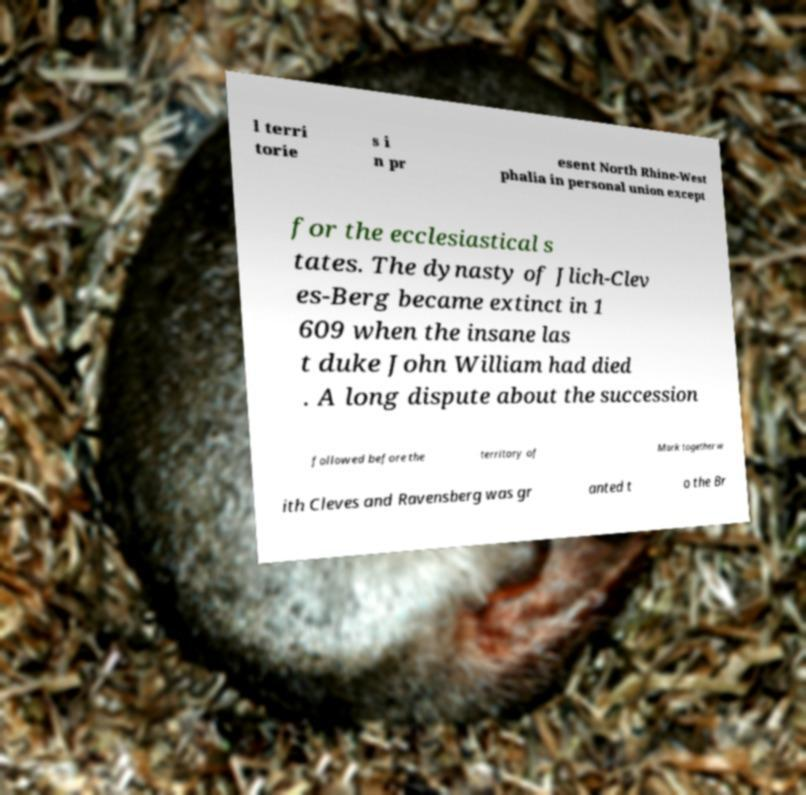What messages or text are displayed in this image? I need them in a readable, typed format. l terri torie s i n pr esent North Rhine-West phalia in personal union except for the ecclesiastical s tates. The dynasty of Jlich-Clev es-Berg became extinct in 1 609 when the insane las t duke John William had died . A long dispute about the succession followed before the territory of Mark together w ith Cleves and Ravensberg was gr anted t o the Br 